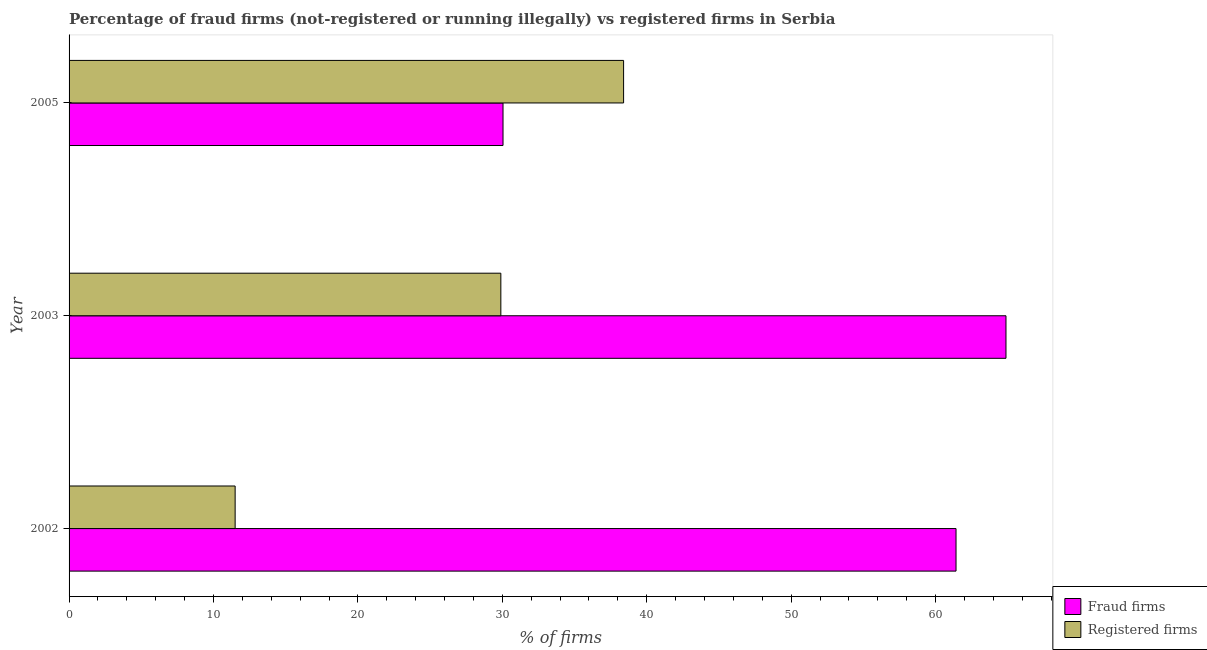How many groups of bars are there?
Keep it short and to the point. 3. Are the number of bars per tick equal to the number of legend labels?
Your response must be concise. Yes. Are the number of bars on each tick of the Y-axis equal?
Your response must be concise. Yes. How many bars are there on the 2nd tick from the top?
Your answer should be very brief. 2. What is the label of the 3rd group of bars from the top?
Provide a short and direct response. 2002. What is the percentage of fraud firms in 2003?
Your response must be concise. 64.88. Across all years, what is the maximum percentage of registered firms?
Provide a short and direct response. 38.4. Across all years, what is the minimum percentage of fraud firms?
Offer a very short reply. 30.05. In which year was the percentage of registered firms minimum?
Keep it short and to the point. 2002. What is the total percentage of fraud firms in the graph?
Your response must be concise. 156.35. What is the difference between the percentage of registered firms in 2002 and the percentage of fraud firms in 2005?
Offer a very short reply. -18.55. What is the average percentage of registered firms per year?
Provide a succinct answer. 26.6. In the year 2002, what is the difference between the percentage of fraud firms and percentage of registered firms?
Make the answer very short. 49.92. What is the ratio of the percentage of registered firms in 2002 to that in 2003?
Make the answer very short. 0.39. Is the percentage of registered firms in 2002 less than that in 2003?
Make the answer very short. Yes. What is the difference between the highest and the second highest percentage of fraud firms?
Provide a short and direct response. 3.46. What is the difference between the highest and the lowest percentage of registered firms?
Offer a very short reply. 26.9. What does the 1st bar from the top in 2003 represents?
Your answer should be compact. Registered firms. What does the 2nd bar from the bottom in 2002 represents?
Give a very brief answer. Registered firms. What is the difference between two consecutive major ticks on the X-axis?
Your answer should be very brief. 10. Are the values on the major ticks of X-axis written in scientific E-notation?
Ensure brevity in your answer.  No. Where does the legend appear in the graph?
Provide a succinct answer. Bottom right. How many legend labels are there?
Ensure brevity in your answer.  2. How are the legend labels stacked?
Provide a succinct answer. Vertical. What is the title of the graph?
Keep it short and to the point. Percentage of fraud firms (not-registered or running illegally) vs registered firms in Serbia. What is the label or title of the X-axis?
Keep it short and to the point. % of firms. What is the label or title of the Y-axis?
Offer a terse response. Year. What is the % of firms of Fraud firms in 2002?
Make the answer very short. 61.42. What is the % of firms in Registered firms in 2002?
Keep it short and to the point. 11.5. What is the % of firms of Fraud firms in 2003?
Offer a terse response. 64.88. What is the % of firms of Registered firms in 2003?
Make the answer very short. 29.9. What is the % of firms of Fraud firms in 2005?
Your response must be concise. 30.05. What is the % of firms of Registered firms in 2005?
Your answer should be compact. 38.4. Across all years, what is the maximum % of firms in Fraud firms?
Provide a succinct answer. 64.88. Across all years, what is the maximum % of firms of Registered firms?
Your response must be concise. 38.4. Across all years, what is the minimum % of firms in Fraud firms?
Provide a succinct answer. 30.05. What is the total % of firms in Fraud firms in the graph?
Offer a very short reply. 156.35. What is the total % of firms of Registered firms in the graph?
Make the answer very short. 79.8. What is the difference between the % of firms in Fraud firms in 2002 and that in 2003?
Offer a very short reply. -3.46. What is the difference between the % of firms in Registered firms in 2002 and that in 2003?
Give a very brief answer. -18.4. What is the difference between the % of firms of Fraud firms in 2002 and that in 2005?
Your answer should be compact. 31.37. What is the difference between the % of firms of Registered firms in 2002 and that in 2005?
Offer a very short reply. -26.9. What is the difference between the % of firms of Fraud firms in 2003 and that in 2005?
Your answer should be compact. 34.83. What is the difference between the % of firms of Fraud firms in 2002 and the % of firms of Registered firms in 2003?
Your answer should be very brief. 31.52. What is the difference between the % of firms of Fraud firms in 2002 and the % of firms of Registered firms in 2005?
Keep it short and to the point. 23.02. What is the difference between the % of firms of Fraud firms in 2003 and the % of firms of Registered firms in 2005?
Provide a short and direct response. 26.48. What is the average % of firms in Fraud firms per year?
Keep it short and to the point. 52.12. What is the average % of firms of Registered firms per year?
Give a very brief answer. 26.6. In the year 2002, what is the difference between the % of firms of Fraud firms and % of firms of Registered firms?
Provide a succinct answer. 49.92. In the year 2003, what is the difference between the % of firms of Fraud firms and % of firms of Registered firms?
Make the answer very short. 34.98. In the year 2005, what is the difference between the % of firms in Fraud firms and % of firms in Registered firms?
Your answer should be very brief. -8.35. What is the ratio of the % of firms of Fraud firms in 2002 to that in 2003?
Your answer should be compact. 0.95. What is the ratio of the % of firms in Registered firms in 2002 to that in 2003?
Give a very brief answer. 0.38. What is the ratio of the % of firms of Fraud firms in 2002 to that in 2005?
Give a very brief answer. 2.04. What is the ratio of the % of firms in Registered firms in 2002 to that in 2005?
Provide a short and direct response. 0.3. What is the ratio of the % of firms of Fraud firms in 2003 to that in 2005?
Offer a very short reply. 2.16. What is the ratio of the % of firms of Registered firms in 2003 to that in 2005?
Keep it short and to the point. 0.78. What is the difference between the highest and the second highest % of firms of Fraud firms?
Ensure brevity in your answer.  3.46. What is the difference between the highest and the lowest % of firms of Fraud firms?
Provide a succinct answer. 34.83. What is the difference between the highest and the lowest % of firms of Registered firms?
Provide a short and direct response. 26.9. 